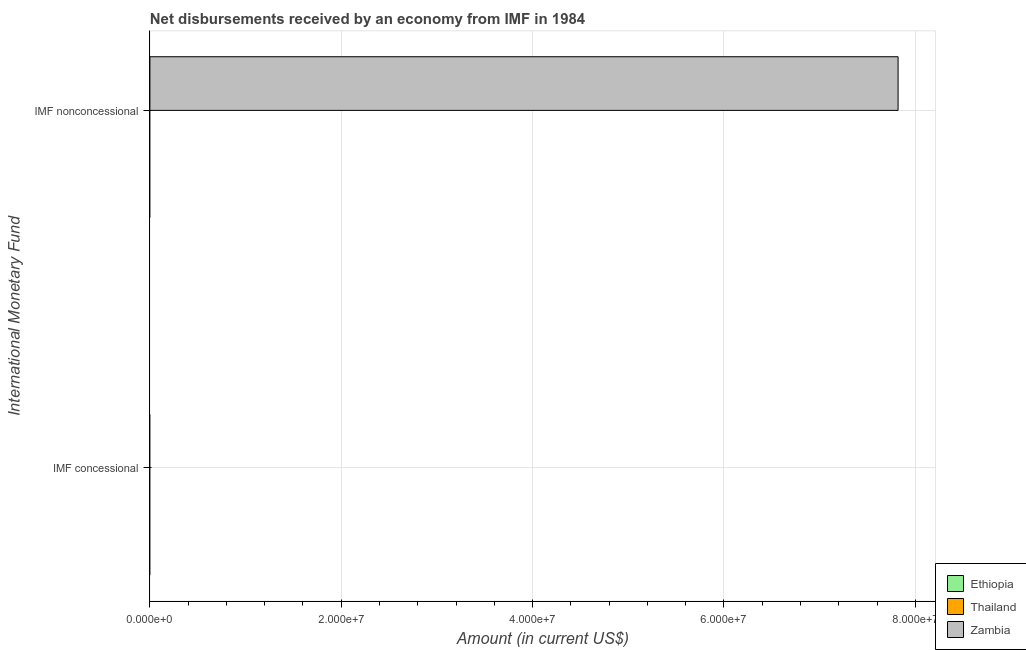Are the number of bars on each tick of the Y-axis equal?
Keep it short and to the point. No. How many bars are there on the 2nd tick from the top?
Your answer should be compact. 0. How many bars are there on the 2nd tick from the bottom?
Provide a short and direct response. 1. What is the label of the 2nd group of bars from the top?
Your answer should be very brief. IMF concessional. What is the net non concessional disbursements from imf in Zambia?
Ensure brevity in your answer.  7.82e+07. Across all countries, what is the maximum net non concessional disbursements from imf?
Ensure brevity in your answer.  7.82e+07. Across all countries, what is the minimum net concessional disbursements from imf?
Provide a short and direct response. 0. In which country was the net non concessional disbursements from imf maximum?
Provide a short and direct response. Zambia. What is the total net non concessional disbursements from imf in the graph?
Provide a short and direct response. 7.82e+07. What is the difference between the net concessional disbursements from imf in Thailand and the net non concessional disbursements from imf in Zambia?
Offer a terse response. -7.82e+07. In how many countries, is the net non concessional disbursements from imf greater than the average net non concessional disbursements from imf taken over all countries?
Offer a terse response. 1. Are all the bars in the graph horizontal?
Offer a very short reply. Yes. How many countries are there in the graph?
Your answer should be compact. 3. What is the difference between two consecutive major ticks on the X-axis?
Keep it short and to the point. 2.00e+07. Are the values on the major ticks of X-axis written in scientific E-notation?
Offer a very short reply. Yes. Does the graph contain any zero values?
Your answer should be compact. Yes. How many legend labels are there?
Provide a short and direct response. 3. What is the title of the graph?
Offer a very short reply. Net disbursements received by an economy from IMF in 1984. What is the label or title of the X-axis?
Offer a terse response. Amount (in current US$). What is the label or title of the Y-axis?
Make the answer very short. International Monetary Fund. What is the Amount (in current US$) in Thailand in IMF concessional?
Offer a terse response. 0. What is the Amount (in current US$) of Zambia in IMF concessional?
Offer a terse response. 0. What is the Amount (in current US$) of Thailand in IMF nonconcessional?
Provide a succinct answer. 0. What is the Amount (in current US$) of Zambia in IMF nonconcessional?
Offer a very short reply. 7.82e+07. Across all International Monetary Fund, what is the maximum Amount (in current US$) of Zambia?
Your answer should be compact. 7.82e+07. Across all International Monetary Fund, what is the minimum Amount (in current US$) in Zambia?
Your response must be concise. 0. What is the total Amount (in current US$) in Ethiopia in the graph?
Make the answer very short. 0. What is the total Amount (in current US$) in Thailand in the graph?
Your response must be concise. 0. What is the total Amount (in current US$) in Zambia in the graph?
Offer a very short reply. 7.82e+07. What is the average Amount (in current US$) of Ethiopia per International Monetary Fund?
Keep it short and to the point. 0. What is the average Amount (in current US$) in Zambia per International Monetary Fund?
Your response must be concise. 3.91e+07. What is the difference between the highest and the lowest Amount (in current US$) in Zambia?
Offer a very short reply. 7.82e+07. 